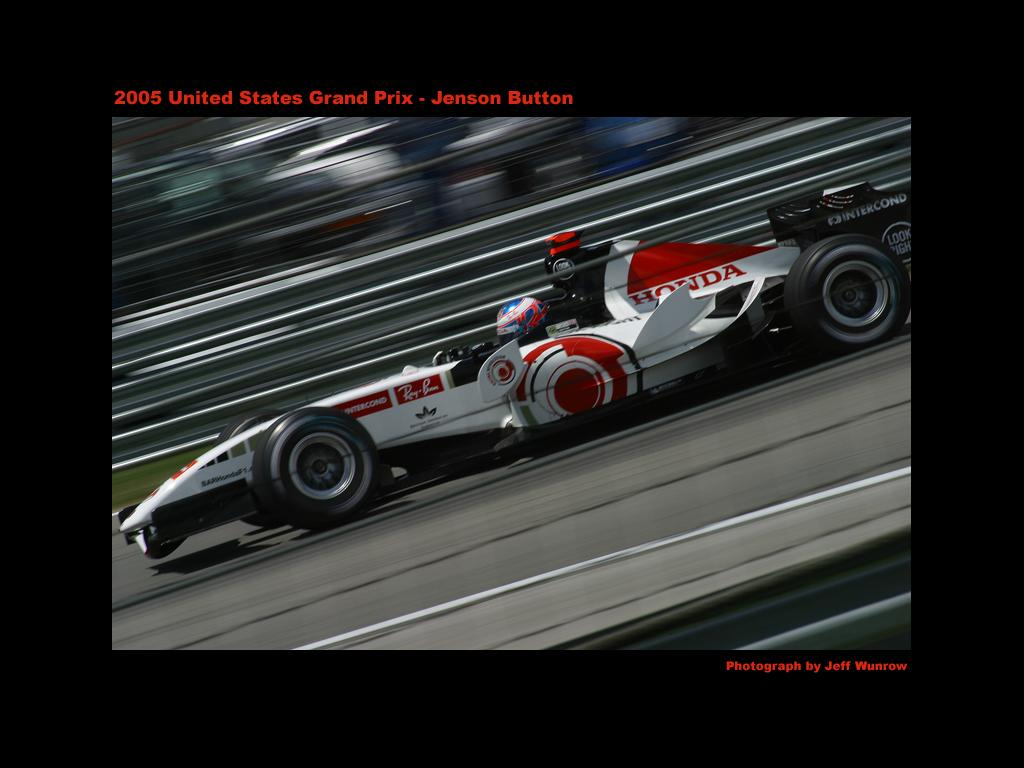What is the main subject of the image? The main subject of the image is a racing car. Can you describe the car's state in the image? The image is captured while the car is in motion. What type of bells can be heard ringing in the image? There are no bells present in the image, and therefore no sound can be heard. 